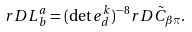<formula> <loc_0><loc_0><loc_500><loc_500>r D L ^ { a } _ { b } = ( \det e ^ { k } _ { d } ) ^ { - 8 } r D \tilde { C } _ { \beta \pi } .</formula> 